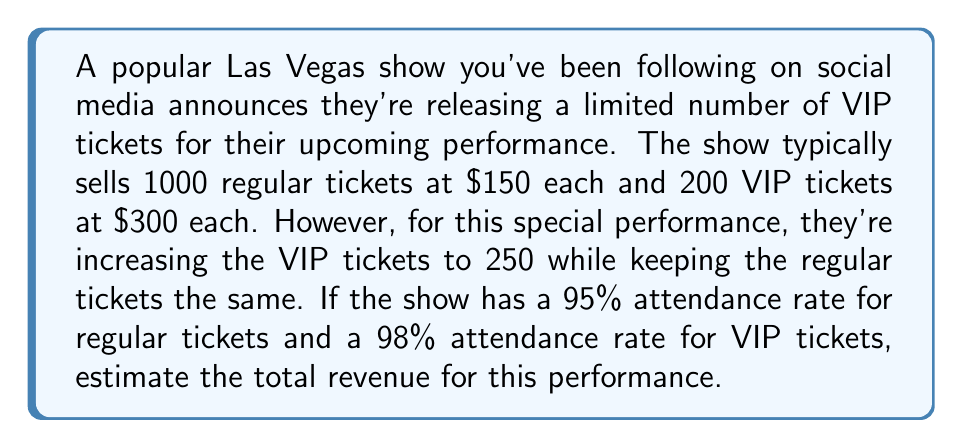Could you help me with this problem? Let's break this down step-by-step:

1. Calculate the expected number of attendees:
   - Regular tickets: $1000 \times 0.95 = 950$ attendees
   - VIP tickets: $250 \times 0.98 = 245$ attendees

2. Calculate the revenue from regular tickets:
   $$ R_{regular} = 950 \times \$150 = \$142,500 $$

3. Calculate the revenue from VIP tickets:
   $$ R_{VIP} = 245 \times \$300 = \$73,500 $$

4. Sum up the total revenue:
   $$ R_{total} = R_{regular} + R_{VIP} = \$142,500 + \$73,500 = \$216,000 $$

Therefore, the estimated total revenue for this performance is $\$216,000$.
Answer: $\$216,000$ 